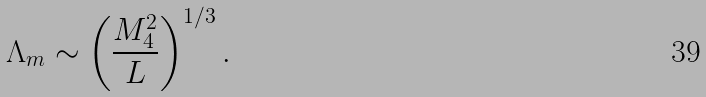Convert formula to latex. <formula><loc_0><loc_0><loc_500><loc_500>\Lambda _ { m } \sim \left ( \frac { M _ { 4 } ^ { 2 } } { L } \right ) ^ { 1 / 3 } .</formula> 